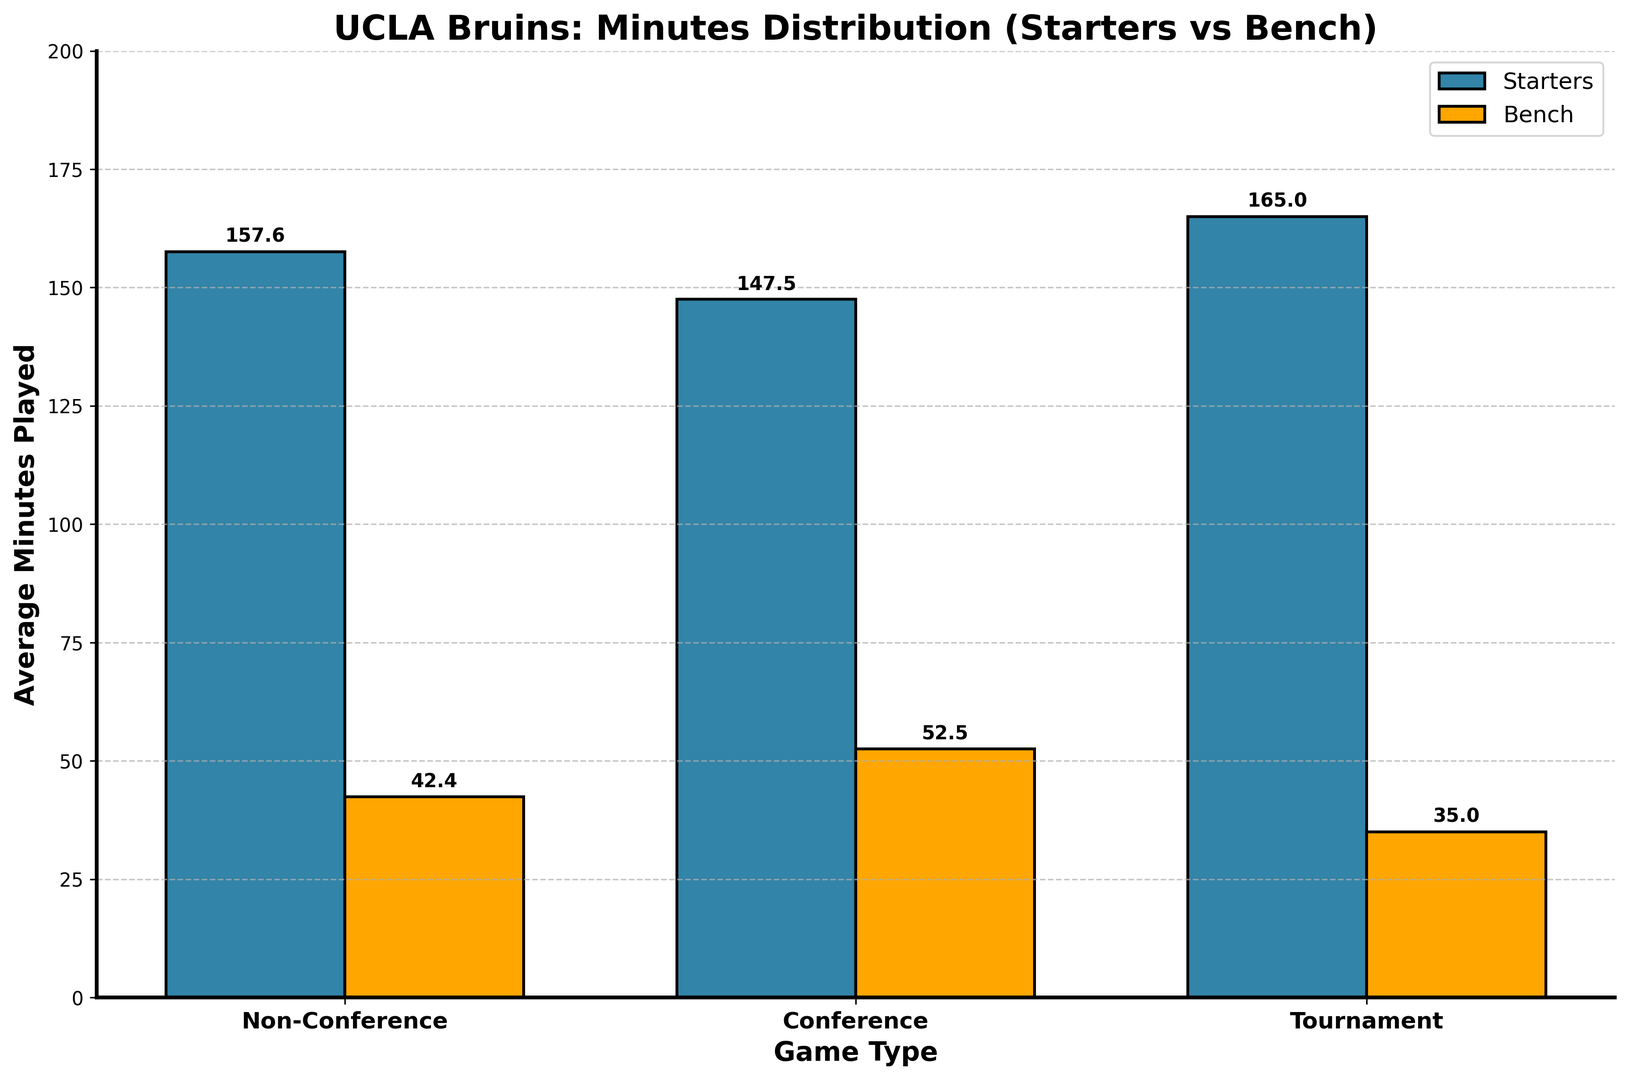What's the average minutes played by starters in Conference games? The average minutes for starters in Conference games can be found by averaging the starter minutes for all Conference entries. The data points are 160, 155, 165, 150, and 158. Adding these gives 788, and dividing by 5 gives approximately 157.6.
Answer: 157.6 How much more on average do starters play compared to bench players in Non-Conference games? First, find the average minutes for starters and bench players in Non-Conference games separately. Starters played 145, 150, 140, and 155 minutes, resulting in an average of 147.5. Bench players played 55, 50, 60, and 45 minutes, resulting in an average of 52.5. The difference is 147.5 - 52.5 = 95.
Answer: 95 Which game type shows the least amount of minutes played by bench players on average? Average the bench minutes played in each game type. For Non-Conference: (55 + 50 + 60 + 45) / 4 = 52.5. For Conference: (40 + 45 + 35 + 50 + 42) / 5 = 42.4. For Tournament: (30 + 35 + 40) / 3 = 35. Tournament games have the lowest average bench minutes at 35.
Answer: Tournament In which game type do starters play the most minutes on average? Compute the average starter minutes for each game type. Non-Conference: (145 + 150 + 140 + 155) / 4 = 147.5. Conference: (160 + 155 + 165 + 150 + 158) / 5 = 157.6. Tournament: (170 + 165 + 160) / 3 = 165. Tournament games have the highest average starter minutes at 165.
Answer: Tournament Is there a significant difference between the average minutes played by the bench and starters in Tournament games? Compare the averages: Tournament starter minutes are (170 + 165 + 160) / 3 = 165. Tournament bench minutes are (30 + 35 + 40) / 3 = 35. The difference is 165 - 35 = 130. This indicates a significant difference.
Answer: Yes Which category, bench or starters, shows the most consistent minutes across Conference games based on the plot? Consistency can often be judged by the range or spread of the values. For starters in Conference games, the minutes vary from 150 to 165, while for bench players, they vary from 35 to 50. Thus, starters have a narrower range (15 minutes) compared to the bench (15 minutes).
Answer: Starters 